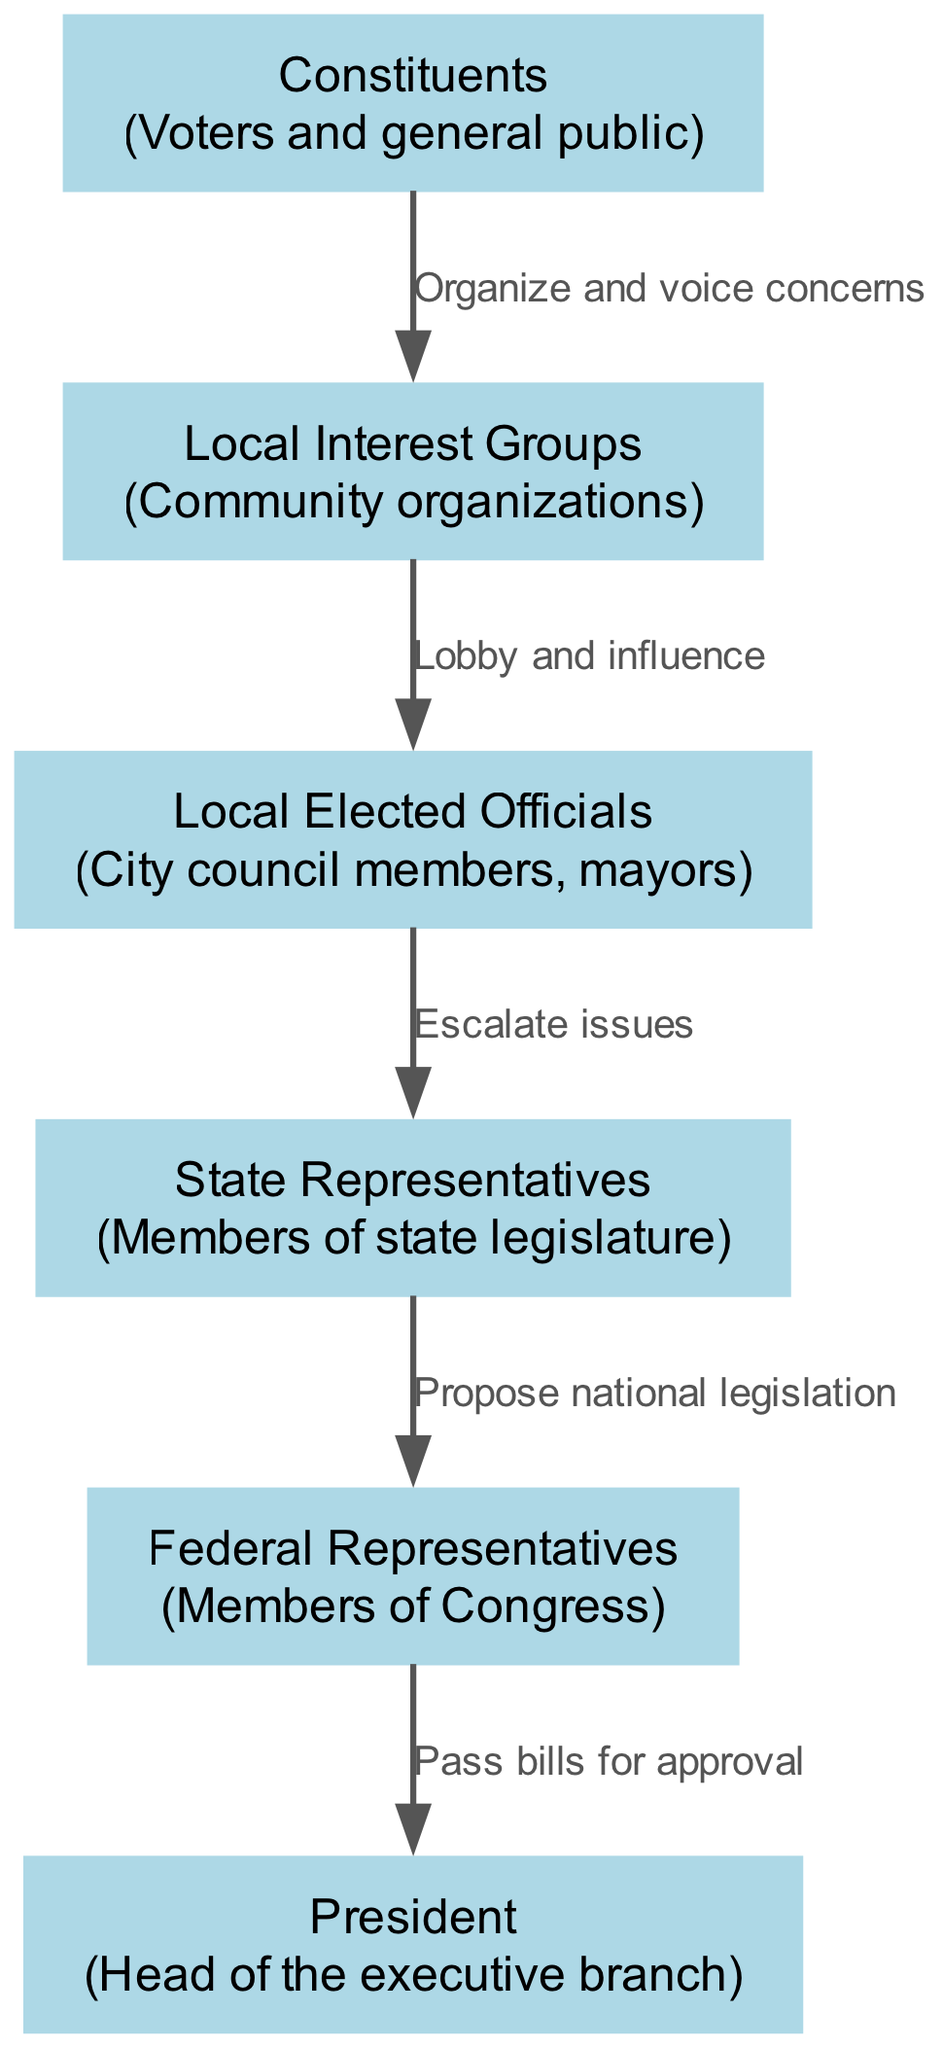What is the first node in the food chain? The first node in the food chain is "Constituents," which represents the voters and general public. This can be identified as the starting point with arrows leading to the next node.
Answer: Constituents How many total nodes are in the diagram? By counting each unique element category, we recognize there are seven key nodes: constituents, local interest groups, local elected officials, state representatives, federal representatives, and president.
Answer: Seven What relationship exists between local groups and local officials? The relationship described is "Lobby and influence." This indicates that local interest groups communicate and attempt to sway the actions or opinions of local elected officials, as shown by the directed arrow connecting these two nodes.
Answer: Lobby and influence Which node escalates issues to state representatives? The "Local Elected Officials" node is responsible for escalating issues to state representatives. The connecting arrow suggests that local officials engage with state-level representatives for addressing concerns at a higher governmental level.
Answer: Local Officials What is the last action in the food chain process? The last action is "Pass bills for approval," which happens at the connection from federal representatives to the president, indicating that federal legislation reached the executive branch for final approval.
Answer: Pass bills for approval How many edges are there in the diagram? There are five directed edges in the food chain diagram, each representing a relationship between two nodes, as evidenced by the connections made between different levels of government representation.
Answer: Five What do constituents do to influence local groups? Constituents "Organize and voice concerns," which illustrates their role in mobilizing and communicating their interests or issues to local interest groups that represent them.
Answer: Organize and voice concerns Which node proposes national legislation to federal representatives? The "State Representatives" node proposes national legislation to federal representatives, as indicated by the arrow pointing from state reps to federal reps in the flow of information.
Answer: State Representatives What type of groups do constituents organize? Constituents organize "Local Interest Groups" which signifies the formation of community-based groups that advocate for specific issues or concerns among the public.
Answer: Local Interest Groups 